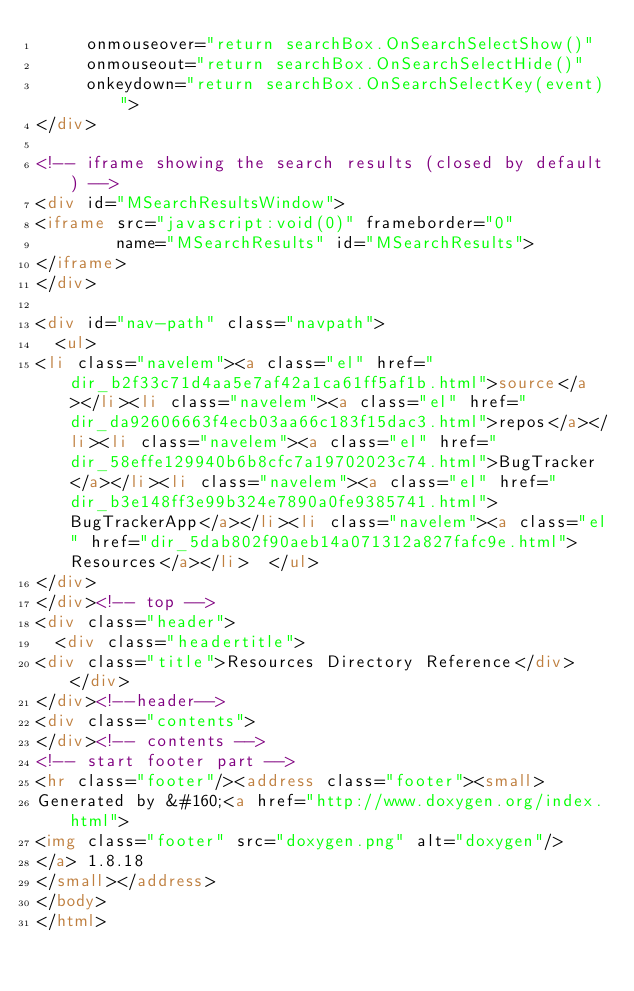<code> <loc_0><loc_0><loc_500><loc_500><_HTML_>     onmouseover="return searchBox.OnSearchSelectShow()"
     onmouseout="return searchBox.OnSearchSelectHide()"
     onkeydown="return searchBox.OnSearchSelectKey(event)">
</div>

<!-- iframe showing the search results (closed by default) -->
<div id="MSearchResultsWindow">
<iframe src="javascript:void(0)" frameborder="0" 
        name="MSearchResults" id="MSearchResults">
</iframe>
</div>

<div id="nav-path" class="navpath">
  <ul>
<li class="navelem"><a class="el" href="dir_b2f33c71d4aa5e7af42a1ca61ff5af1b.html">source</a></li><li class="navelem"><a class="el" href="dir_da92606663f4ecb03aa66c183f15dac3.html">repos</a></li><li class="navelem"><a class="el" href="dir_58effe129940b6b8cfc7a19702023c74.html">BugTracker</a></li><li class="navelem"><a class="el" href="dir_b3e148ff3e99b324e7890a0fe9385741.html">BugTrackerApp</a></li><li class="navelem"><a class="el" href="dir_5dab802f90aeb14a071312a827fafc9e.html">Resources</a></li>  </ul>
</div>
</div><!-- top -->
<div class="header">
  <div class="headertitle">
<div class="title">Resources Directory Reference</div>  </div>
</div><!--header-->
<div class="contents">
</div><!-- contents -->
<!-- start footer part -->
<hr class="footer"/><address class="footer"><small>
Generated by &#160;<a href="http://www.doxygen.org/index.html">
<img class="footer" src="doxygen.png" alt="doxygen"/>
</a> 1.8.18
</small></address>
</body>
</html>
</code> 